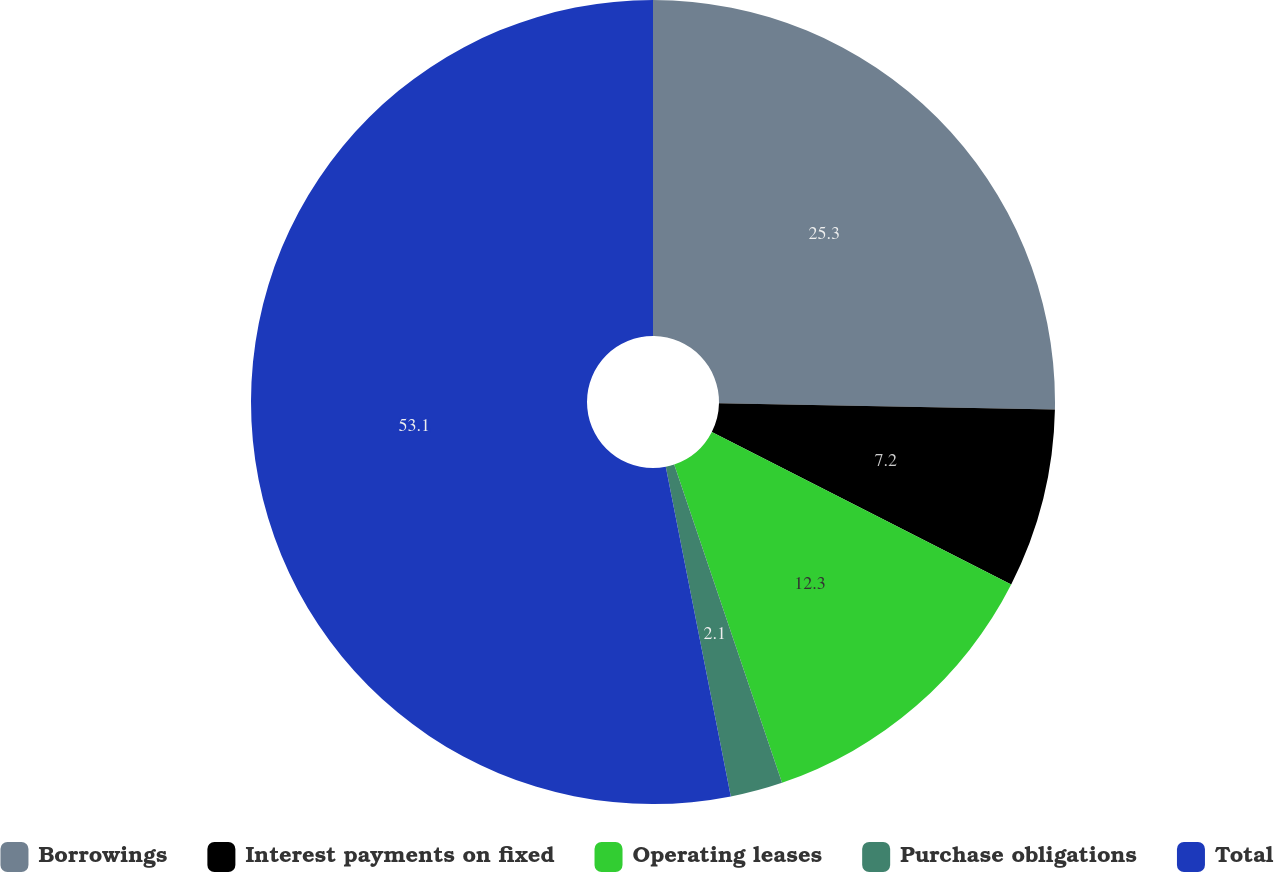Convert chart to OTSL. <chart><loc_0><loc_0><loc_500><loc_500><pie_chart><fcel>Borrowings<fcel>Interest payments on fixed<fcel>Operating leases<fcel>Purchase obligations<fcel>Total<nl><fcel>25.3%<fcel>7.2%<fcel>12.3%<fcel>2.1%<fcel>53.1%<nl></chart> 